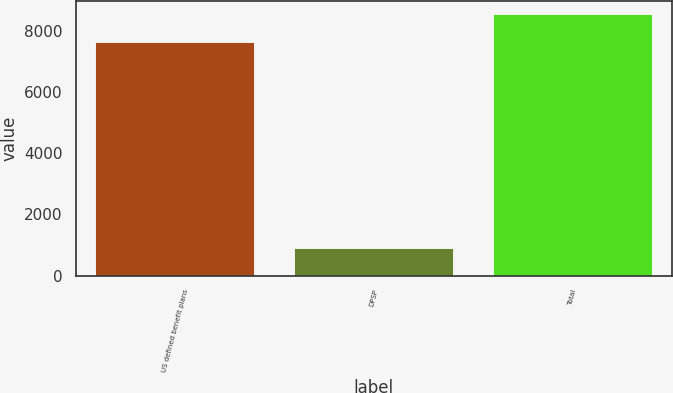Convert chart. <chart><loc_0><loc_0><loc_500><loc_500><bar_chart><fcel>US defined benefit plans<fcel>DPSP<fcel>Total<nl><fcel>7654<fcel>910<fcel>8564<nl></chart> 